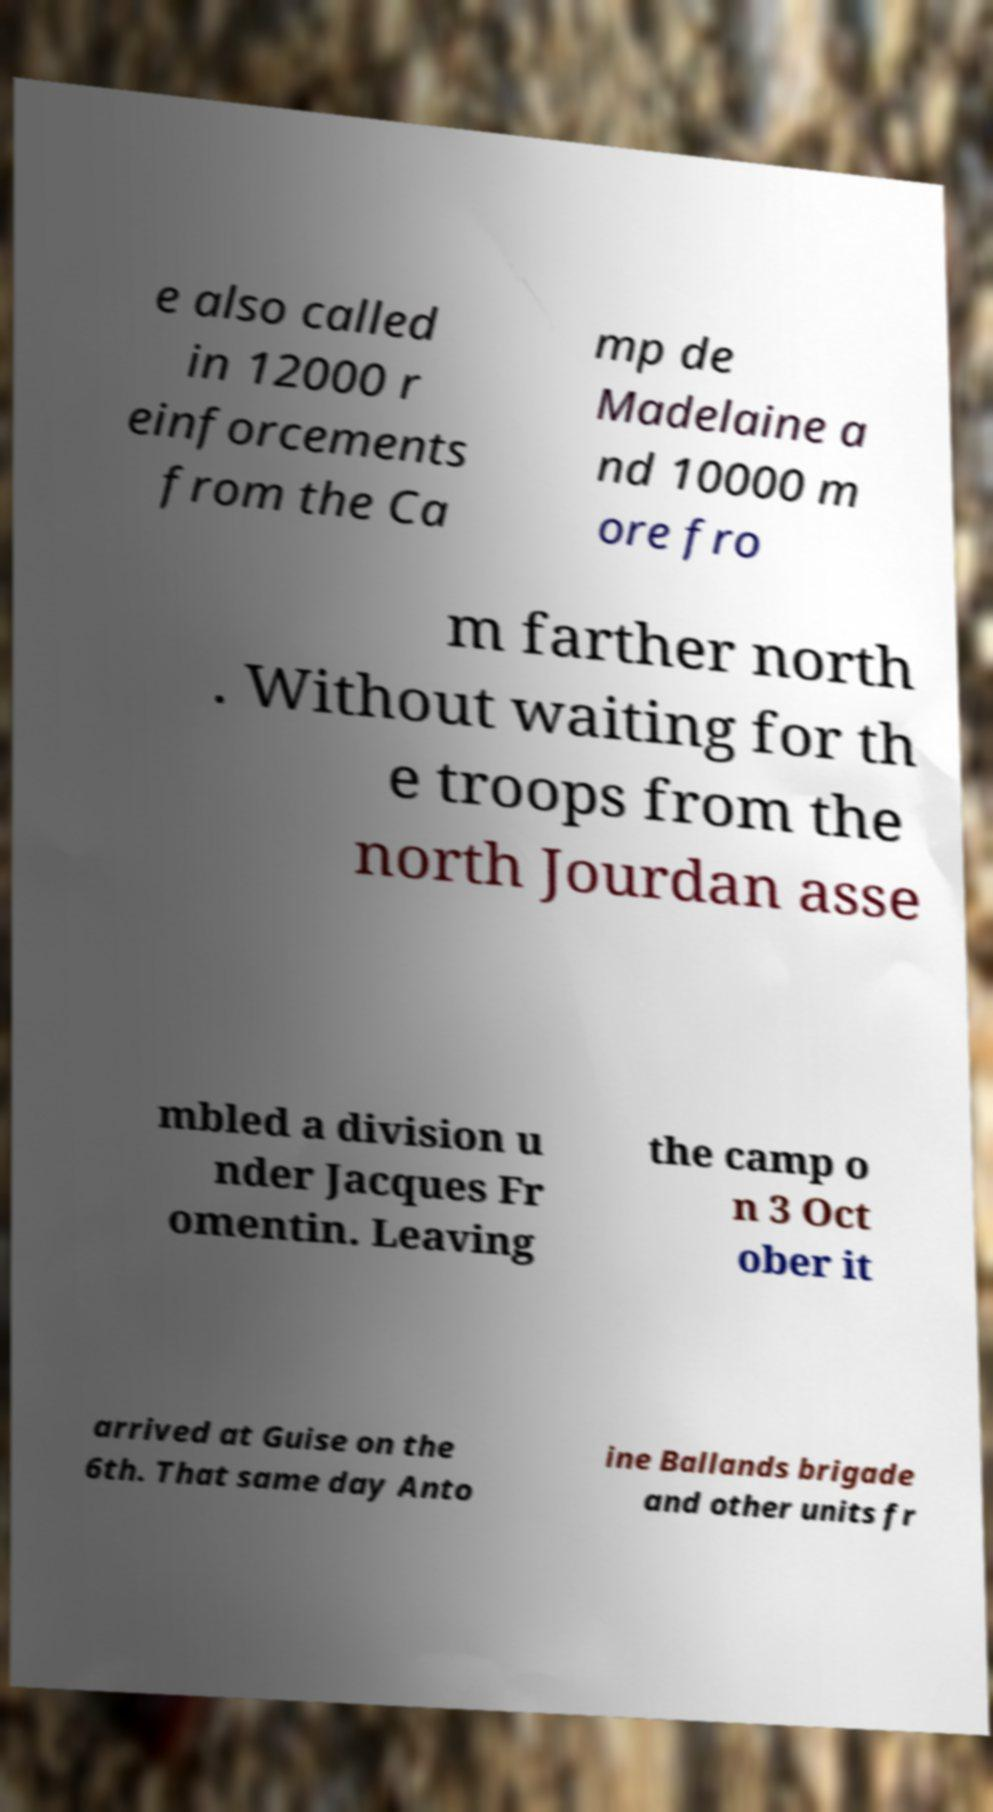Could you assist in decoding the text presented in this image and type it out clearly? e also called in 12000 r einforcements from the Ca mp de Madelaine a nd 10000 m ore fro m farther north . Without waiting for th e troops from the north Jourdan asse mbled a division u nder Jacques Fr omentin. Leaving the camp o n 3 Oct ober it arrived at Guise on the 6th. That same day Anto ine Ballands brigade and other units fr 